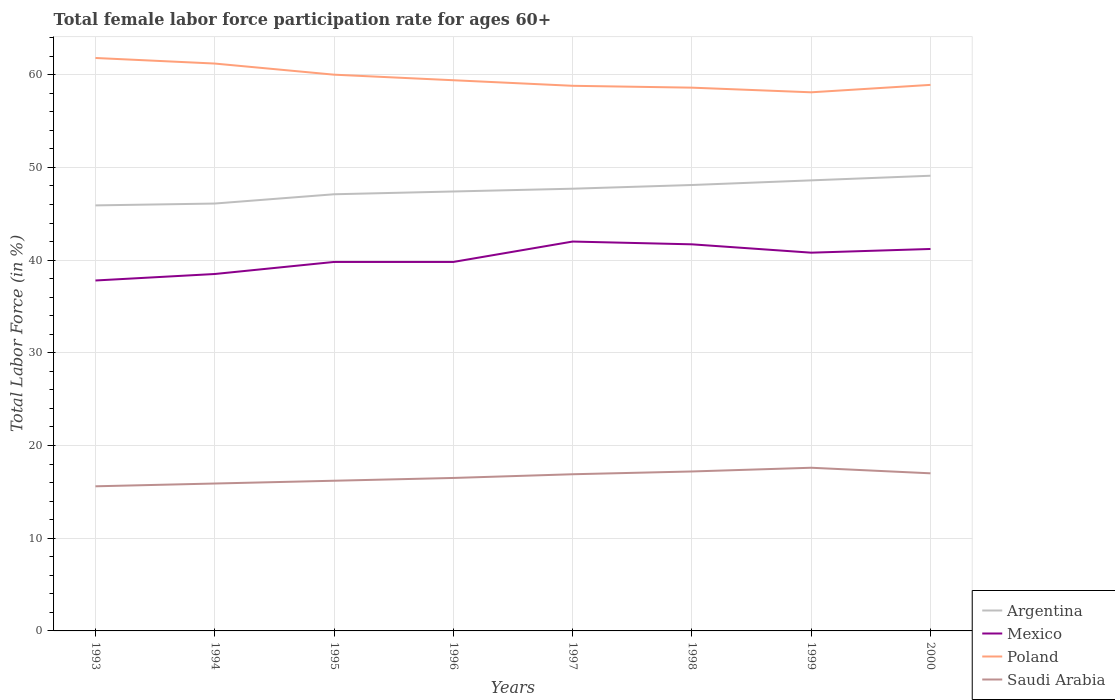Does the line corresponding to Saudi Arabia intersect with the line corresponding to Mexico?
Your answer should be very brief. No. Across all years, what is the maximum female labor force participation rate in Mexico?
Offer a terse response. 37.8. In which year was the female labor force participation rate in Saudi Arabia maximum?
Keep it short and to the point. 1993. What is the total female labor force participation rate in Saudi Arabia in the graph?
Your response must be concise. 0.2. What is the difference between the highest and the second highest female labor force participation rate in Mexico?
Make the answer very short. 4.2. What is the difference between the highest and the lowest female labor force participation rate in Argentina?
Your response must be concise. 4. Is the female labor force participation rate in Saudi Arabia strictly greater than the female labor force participation rate in Mexico over the years?
Make the answer very short. Yes. How many years are there in the graph?
Your response must be concise. 8. What is the difference between two consecutive major ticks on the Y-axis?
Provide a short and direct response. 10. Does the graph contain any zero values?
Make the answer very short. No. Does the graph contain grids?
Your answer should be compact. Yes. Where does the legend appear in the graph?
Your response must be concise. Bottom right. What is the title of the graph?
Your answer should be very brief. Total female labor force participation rate for ages 60+. Does "Curacao" appear as one of the legend labels in the graph?
Provide a succinct answer. No. What is the Total Labor Force (in %) in Argentina in 1993?
Your answer should be very brief. 45.9. What is the Total Labor Force (in %) of Mexico in 1993?
Keep it short and to the point. 37.8. What is the Total Labor Force (in %) of Poland in 1993?
Make the answer very short. 61.8. What is the Total Labor Force (in %) in Saudi Arabia in 1993?
Keep it short and to the point. 15.6. What is the Total Labor Force (in %) of Argentina in 1994?
Provide a short and direct response. 46.1. What is the Total Labor Force (in %) in Mexico in 1994?
Your answer should be compact. 38.5. What is the Total Labor Force (in %) of Poland in 1994?
Provide a succinct answer. 61.2. What is the Total Labor Force (in %) of Saudi Arabia in 1994?
Offer a very short reply. 15.9. What is the Total Labor Force (in %) in Argentina in 1995?
Give a very brief answer. 47.1. What is the Total Labor Force (in %) in Mexico in 1995?
Ensure brevity in your answer.  39.8. What is the Total Labor Force (in %) in Poland in 1995?
Provide a short and direct response. 60. What is the Total Labor Force (in %) of Saudi Arabia in 1995?
Your answer should be compact. 16.2. What is the Total Labor Force (in %) of Argentina in 1996?
Your answer should be compact. 47.4. What is the Total Labor Force (in %) of Mexico in 1996?
Provide a succinct answer. 39.8. What is the Total Labor Force (in %) of Poland in 1996?
Provide a succinct answer. 59.4. What is the Total Labor Force (in %) of Saudi Arabia in 1996?
Ensure brevity in your answer.  16.5. What is the Total Labor Force (in %) of Argentina in 1997?
Your response must be concise. 47.7. What is the Total Labor Force (in %) in Mexico in 1997?
Provide a short and direct response. 42. What is the Total Labor Force (in %) in Poland in 1997?
Offer a very short reply. 58.8. What is the Total Labor Force (in %) in Saudi Arabia in 1997?
Your answer should be very brief. 16.9. What is the Total Labor Force (in %) in Argentina in 1998?
Offer a terse response. 48.1. What is the Total Labor Force (in %) in Mexico in 1998?
Your answer should be compact. 41.7. What is the Total Labor Force (in %) in Poland in 1998?
Offer a terse response. 58.6. What is the Total Labor Force (in %) of Saudi Arabia in 1998?
Offer a terse response. 17.2. What is the Total Labor Force (in %) of Argentina in 1999?
Your answer should be very brief. 48.6. What is the Total Labor Force (in %) of Mexico in 1999?
Make the answer very short. 40.8. What is the Total Labor Force (in %) in Poland in 1999?
Your answer should be compact. 58.1. What is the Total Labor Force (in %) in Saudi Arabia in 1999?
Provide a short and direct response. 17.6. What is the Total Labor Force (in %) of Argentina in 2000?
Your answer should be compact. 49.1. What is the Total Labor Force (in %) in Mexico in 2000?
Give a very brief answer. 41.2. What is the Total Labor Force (in %) in Poland in 2000?
Make the answer very short. 58.9. Across all years, what is the maximum Total Labor Force (in %) of Argentina?
Give a very brief answer. 49.1. Across all years, what is the maximum Total Labor Force (in %) of Poland?
Offer a very short reply. 61.8. Across all years, what is the maximum Total Labor Force (in %) in Saudi Arabia?
Provide a succinct answer. 17.6. Across all years, what is the minimum Total Labor Force (in %) in Argentina?
Offer a very short reply. 45.9. Across all years, what is the minimum Total Labor Force (in %) of Mexico?
Your response must be concise. 37.8. Across all years, what is the minimum Total Labor Force (in %) of Poland?
Offer a very short reply. 58.1. Across all years, what is the minimum Total Labor Force (in %) in Saudi Arabia?
Offer a terse response. 15.6. What is the total Total Labor Force (in %) of Argentina in the graph?
Your answer should be compact. 380. What is the total Total Labor Force (in %) of Mexico in the graph?
Ensure brevity in your answer.  321.6. What is the total Total Labor Force (in %) in Poland in the graph?
Give a very brief answer. 476.8. What is the total Total Labor Force (in %) of Saudi Arabia in the graph?
Provide a succinct answer. 132.9. What is the difference between the Total Labor Force (in %) of Mexico in 1993 and that in 1994?
Make the answer very short. -0.7. What is the difference between the Total Labor Force (in %) of Poland in 1993 and that in 1994?
Make the answer very short. 0.6. What is the difference between the Total Labor Force (in %) of Saudi Arabia in 1993 and that in 1994?
Provide a succinct answer. -0.3. What is the difference between the Total Labor Force (in %) of Argentina in 1993 and that in 1995?
Provide a short and direct response. -1.2. What is the difference between the Total Labor Force (in %) of Mexico in 1993 and that in 1995?
Ensure brevity in your answer.  -2. What is the difference between the Total Labor Force (in %) in Saudi Arabia in 1993 and that in 1995?
Your response must be concise. -0.6. What is the difference between the Total Labor Force (in %) in Argentina in 1993 and that in 1996?
Your response must be concise. -1.5. What is the difference between the Total Labor Force (in %) in Poland in 1993 and that in 1996?
Your response must be concise. 2.4. What is the difference between the Total Labor Force (in %) in Saudi Arabia in 1993 and that in 1996?
Your response must be concise. -0.9. What is the difference between the Total Labor Force (in %) in Argentina in 1993 and that in 1997?
Your answer should be compact. -1.8. What is the difference between the Total Labor Force (in %) of Mexico in 1993 and that in 1997?
Provide a succinct answer. -4.2. What is the difference between the Total Labor Force (in %) in Mexico in 1993 and that in 1998?
Provide a succinct answer. -3.9. What is the difference between the Total Labor Force (in %) in Poland in 1993 and that in 1998?
Provide a succinct answer. 3.2. What is the difference between the Total Labor Force (in %) in Saudi Arabia in 1993 and that in 1998?
Your answer should be compact. -1.6. What is the difference between the Total Labor Force (in %) in Argentina in 1993 and that in 1999?
Ensure brevity in your answer.  -2.7. What is the difference between the Total Labor Force (in %) in Mexico in 1993 and that in 1999?
Your response must be concise. -3. What is the difference between the Total Labor Force (in %) in Poland in 1993 and that in 1999?
Offer a very short reply. 3.7. What is the difference between the Total Labor Force (in %) in Saudi Arabia in 1993 and that in 1999?
Keep it short and to the point. -2. What is the difference between the Total Labor Force (in %) of Argentina in 1993 and that in 2000?
Offer a terse response. -3.2. What is the difference between the Total Labor Force (in %) of Mexico in 1993 and that in 2000?
Provide a short and direct response. -3.4. What is the difference between the Total Labor Force (in %) of Poland in 1993 and that in 2000?
Provide a succinct answer. 2.9. What is the difference between the Total Labor Force (in %) of Argentina in 1994 and that in 1995?
Give a very brief answer. -1. What is the difference between the Total Labor Force (in %) in Poland in 1994 and that in 1995?
Your response must be concise. 1.2. What is the difference between the Total Labor Force (in %) of Poland in 1994 and that in 1996?
Offer a very short reply. 1.8. What is the difference between the Total Labor Force (in %) of Saudi Arabia in 1994 and that in 1996?
Your answer should be very brief. -0.6. What is the difference between the Total Labor Force (in %) of Argentina in 1994 and that in 1997?
Your answer should be very brief. -1.6. What is the difference between the Total Labor Force (in %) of Poland in 1994 and that in 1997?
Keep it short and to the point. 2.4. What is the difference between the Total Labor Force (in %) of Saudi Arabia in 1994 and that in 1998?
Your answer should be compact. -1.3. What is the difference between the Total Labor Force (in %) in Argentina in 1994 and that in 1999?
Make the answer very short. -2.5. What is the difference between the Total Labor Force (in %) of Saudi Arabia in 1994 and that in 1999?
Offer a terse response. -1.7. What is the difference between the Total Labor Force (in %) of Poland in 1994 and that in 2000?
Make the answer very short. 2.3. What is the difference between the Total Labor Force (in %) in Saudi Arabia in 1994 and that in 2000?
Ensure brevity in your answer.  -1.1. What is the difference between the Total Labor Force (in %) of Argentina in 1995 and that in 1996?
Your answer should be compact. -0.3. What is the difference between the Total Labor Force (in %) in Mexico in 1995 and that in 1997?
Give a very brief answer. -2.2. What is the difference between the Total Labor Force (in %) of Saudi Arabia in 1995 and that in 1997?
Keep it short and to the point. -0.7. What is the difference between the Total Labor Force (in %) in Poland in 1995 and that in 1998?
Give a very brief answer. 1.4. What is the difference between the Total Labor Force (in %) of Saudi Arabia in 1995 and that in 1998?
Provide a short and direct response. -1. What is the difference between the Total Labor Force (in %) in Argentina in 1995 and that in 1999?
Give a very brief answer. -1.5. What is the difference between the Total Labor Force (in %) of Poland in 1995 and that in 1999?
Give a very brief answer. 1.9. What is the difference between the Total Labor Force (in %) of Mexico in 1995 and that in 2000?
Make the answer very short. -1.4. What is the difference between the Total Labor Force (in %) of Poland in 1995 and that in 2000?
Provide a short and direct response. 1.1. What is the difference between the Total Labor Force (in %) of Mexico in 1996 and that in 1997?
Your response must be concise. -2.2. What is the difference between the Total Labor Force (in %) in Poland in 1996 and that in 1997?
Your response must be concise. 0.6. What is the difference between the Total Labor Force (in %) in Saudi Arabia in 1996 and that in 1997?
Offer a terse response. -0.4. What is the difference between the Total Labor Force (in %) of Mexico in 1996 and that in 1999?
Offer a terse response. -1. What is the difference between the Total Labor Force (in %) in Argentina in 1996 and that in 2000?
Provide a short and direct response. -1.7. What is the difference between the Total Labor Force (in %) in Mexico in 1996 and that in 2000?
Your answer should be compact. -1.4. What is the difference between the Total Labor Force (in %) of Argentina in 1997 and that in 1998?
Provide a succinct answer. -0.4. What is the difference between the Total Labor Force (in %) of Mexico in 1997 and that in 1998?
Provide a short and direct response. 0.3. What is the difference between the Total Labor Force (in %) in Saudi Arabia in 1997 and that in 1998?
Your response must be concise. -0.3. What is the difference between the Total Labor Force (in %) in Mexico in 1997 and that in 1999?
Provide a succinct answer. 1.2. What is the difference between the Total Labor Force (in %) of Saudi Arabia in 1997 and that in 1999?
Offer a very short reply. -0.7. What is the difference between the Total Labor Force (in %) of Argentina in 1997 and that in 2000?
Your response must be concise. -1.4. What is the difference between the Total Labor Force (in %) in Mexico in 1997 and that in 2000?
Ensure brevity in your answer.  0.8. What is the difference between the Total Labor Force (in %) in Argentina in 1998 and that in 1999?
Your answer should be compact. -0.5. What is the difference between the Total Labor Force (in %) in Poland in 1998 and that in 1999?
Provide a succinct answer. 0.5. What is the difference between the Total Labor Force (in %) in Saudi Arabia in 1998 and that in 1999?
Keep it short and to the point. -0.4. What is the difference between the Total Labor Force (in %) in Mexico in 1998 and that in 2000?
Your answer should be compact. 0.5. What is the difference between the Total Labor Force (in %) of Saudi Arabia in 1998 and that in 2000?
Your response must be concise. 0.2. What is the difference between the Total Labor Force (in %) of Argentina in 1999 and that in 2000?
Provide a short and direct response. -0.5. What is the difference between the Total Labor Force (in %) in Mexico in 1999 and that in 2000?
Give a very brief answer. -0.4. What is the difference between the Total Labor Force (in %) of Poland in 1999 and that in 2000?
Keep it short and to the point. -0.8. What is the difference between the Total Labor Force (in %) of Argentina in 1993 and the Total Labor Force (in %) of Poland in 1994?
Your response must be concise. -15.3. What is the difference between the Total Labor Force (in %) of Mexico in 1993 and the Total Labor Force (in %) of Poland in 1994?
Your response must be concise. -23.4. What is the difference between the Total Labor Force (in %) of Mexico in 1993 and the Total Labor Force (in %) of Saudi Arabia in 1994?
Provide a short and direct response. 21.9. What is the difference between the Total Labor Force (in %) in Poland in 1993 and the Total Labor Force (in %) in Saudi Arabia in 1994?
Ensure brevity in your answer.  45.9. What is the difference between the Total Labor Force (in %) in Argentina in 1993 and the Total Labor Force (in %) in Mexico in 1995?
Your response must be concise. 6.1. What is the difference between the Total Labor Force (in %) in Argentina in 1993 and the Total Labor Force (in %) in Poland in 1995?
Offer a terse response. -14.1. What is the difference between the Total Labor Force (in %) of Argentina in 1993 and the Total Labor Force (in %) of Saudi Arabia in 1995?
Provide a short and direct response. 29.7. What is the difference between the Total Labor Force (in %) in Mexico in 1993 and the Total Labor Force (in %) in Poland in 1995?
Make the answer very short. -22.2. What is the difference between the Total Labor Force (in %) in Mexico in 1993 and the Total Labor Force (in %) in Saudi Arabia in 1995?
Make the answer very short. 21.6. What is the difference between the Total Labor Force (in %) of Poland in 1993 and the Total Labor Force (in %) of Saudi Arabia in 1995?
Provide a short and direct response. 45.6. What is the difference between the Total Labor Force (in %) of Argentina in 1993 and the Total Labor Force (in %) of Saudi Arabia in 1996?
Your answer should be compact. 29.4. What is the difference between the Total Labor Force (in %) of Mexico in 1993 and the Total Labor Force (in %) of Poland in 1996?
Your answer should be very brief. -21.6. What is the difference between the Total Labor Force (in %) in Mexico in 1993 and the Total Labor Force (in %) in Saudi Arabia in 1996?
Ensure brevity in your answer.  21.3. What is the difference between the Total Labor Force (in %) in Poland in 1993 and the Total Labor Force (in %) in Saudi Arabia in 1996?
Offer a very short reply. 45.3. What is the difference between the Total Labor Force (in %) of Argentina in 1993 and the Total Labor Force (in %) of Mexico in 1997?
Your answer should be very brief. 3.9. What is the difference between the Total Labor Force (in %) in Mexico in 1993 and the Total Labor Force (in %) in Saudi Arabia in 1997?
Offer a terse response. 20.9. What is the difference between the Total Labor Force (in %) of Poland in 1993 and the Total Labor Force (in %) of Saudi Arabia in 1997?
Give a very brief answer. 44.9. What is the difference between the Total Labor Force (in %) in Argentina in 1993 and the Total Labor Force (in %) in Mexico in 1998?
Your answer should be compact. 4.2. What is the difference between the Total Labor Force (in %) of Argentina in 1993 and the Total Labor Force (in %) of Saudi Arabia in 1998?
Make the answer very short. 28.7. What is the difference between the Total Labor Force (in %) in Mexico in 1993 and the Total Labor Force (in %) in Poland in 1998?
Make the answer very short. -20.8. What is the difference between the Total Labor Force (in %) of Mexico in 1993 and the Total Labor Force (in %) of Saudi Arabia in 1998?
Keep it short and to the point. 20.6. What is the difference between the Total Labor Force (in %) of Poland in 1993 and the Total Labor Force (in %) of Saudi Arabia in 1998?
Your answer should be compact. 44.6. What is the difference between the Total Labor Force (in %) of Argentina in 1993 and the Total Labor Force (in %) of Mexico in 1999?
Provide a short and direct response. 5.1. What is the difference between the Total Labor Force (in %) in Argentina in 1993 and the Total Labor Force (in %) in Poland in 1999?
Provide a short and direct response. -12.2. What is the difference between the Total Labor Force (in %) of Argentina in 1993 and the Total Labor Force (in %) of Saudi Arabia in 1999?
Provide a short and direct response. 28.3. What is the difference between the Total Labor Force (in %) in Mexico in 1993 and the Total Labor Force (in %) in Poland in 1999?
Your answer should be compact. -20.3. What is the difference between the Total Labor Force (in %) of Mexico in 1993 and the Total Labor Force (in %) of Saudi Arabia in 1999?
Make the answer very short. 20.2. What is the difference between the Total Labor Force (in %) of Poland in 1993 and the Total Labor Force (in %) of Saudi Arabia in 1999?
Give a very brief answer. 44.2. What is the difference between the Total Labor Force (in %) of Argentina in 1993 and the Total Labor Force (in %) of Poland in 2000?
Make the answer very short. -13. What is the difference between the Total Labor Force (in %) in Argentina in 1993 and the Total Labor Force (in %) in Saudi Arabia in 2000?
Provide a succinct answer. 28.9. What is the difference between the Total Labor Force (in %) in Mexico in 1993 and the Total Labor Force (in %) in Poland in 2000?
Make the answer very short. -21.1. What is the difference between the Total Labor Force (in %) of Mexico in 1993 and the Total Labor Force (in %) of Saudi Arabia in 2000?
Offer a terse response. 20.8. What is the difference between the Total Labor Force (in %) in Poland in 1993 and the Total Labor Force (in %) in Saudi Arabia in 2000?
Give a very brief answer. 44.8. What is the difference between the Total Labor Force (in %) in Argentina in 1994 and the Total Labor Force (in %) in Mexico in 1995?
Provide a succinct answer. 6.3. What is the difference between the Total Labor Force (in %) in Argentina in 1994 and the Total Labor Force (in %) in Poland in 1995?
Offer a terse response. -13.9. What is the difference between the Total Labor Force (in %) in Argentina in 1994 and the Total Labor Force (in %) in Saudi Arabia in 1995?
Your response must be concise. 29.9. What is the difference between the Total Labor Force (in %) in Mexico in 1994 and the Total Labor Force (in %) in Poland in 1995?
Ensure brevity in your answer.  -21.5. What is the difference between the Total Labor Force (in %) in Mexico in 1994 and the Total Labor Force (in %) in Saudi Arabia in 1995?
Keep it short and to the point. 22.3. What is the difference between the Total Labor Force (in %) in Argentina in 1994 and the Total Labor Force (in %) in Poland in 1996?
Keep it short and to the point. -13.3. What is the difference between the Total Labor Force (in %) of Argentina in 1994 and the Total Labor Force (in %) of Saudi Arabia in 1996?
Make the answer very short. 29.6. What is the difference between the Total Labor Force (in %) in Mexico in 1994 and the Total Labor Force (in %) in Poland in 1996?
Your answer should be very brief. -20.9. What is the difference between the Total Labor Force (in %) of Poland in 1994 and the Total Labor Force (in %) of Saudi Arabia in 1996?
Ensure brevity in your answer.  44.7. What is the difference between the Total Labor Force (in %) in Argentina in 1994 and the Total Labor Force (in %) in Saudi Arabia in 1997?
Ensure brevity in your answer.  29.2. What is the difference between the Total Labor Force (in %) of Mexico in 1994 and the Total Labor Force (in %) of Poland in 1997?
Ensure brevity in your answer.  -20.3. What is the difference between the Total Labor Force (in %) of Mexico in 1994 and the Total Labor Force (in %) of Saudi Arabia in 1997?
Offer a terse response. 21.6. What is the difference between the Total Labor Force (in %) in Poland in 1994 and the Total Labor Force (in %) in Saudi Arabia in 1997?
Keep it short and to the point. 44.3. What is the difference between the Total Labor Force (in %) in Argentina in 1994 and the Total Labor Force (in %) in Mexico in 1998?
Your answer should be compact. 4.4. What is the difference between the Total Labor Force (in %) of Argentina in 1994 and the Total Labor Force (in %) of Poland in 1998?
Your answer should be compact. -12.5. What is the difference between the Total Labor Force (in %) in Argentina in 1994 and the Total Labor Force (in %) in Saudi Arabia in 1998?
Keep it short and to the point. 28.9. What is the difference between the Total Labor Force (in %) of Mexico in 1994 and the Total Labor Force (in %) of Poland in 1998?
Make the answer very short. -20.1. What is the difference between the Total Labor Force (in %) in Mexico in 1994 and the Total Labor Force (in %) in Saudi Arabia in 1998?
Your response must be concise. 21.3. What is the difference between the Total Labor Force (in %) in Poland in 1994 and the Total Labor Force (in %) in Saudi Arabia in 1998?
Give a very brief answer. 44. What is the difference between the Total Labor Force (in %) of Argentina in 1994 and the Total Labor Force (in %) of Mexico in 1999?
Your answer should be compact. 5.3. What is the difference between the Total Labor Force (in %) in Argentina in 1994 and the Total Labor Force (in %) in Saudi Arabia in 1999?
Make the answer very short. 28.5. What is the difference between the Total Labor Force (in %) in Mexico in 1994 and the Total Labor Force (in %) in Poland in 1999?
Your answer should be compact. -19.6. What is the difference between the Total Labor Force (in %) in Mexico in 1994 and the Total Labor Force (in %) in Saudi Arabia in 1999?
Offer a very short reply. 20.9. What is the difference between the Total Labor Force (in %) in Poland in 1994 and the Total Labor Force (in %) in Saudi Arabia in 1999?
Your response must be concise. 43.6. What is the difference between the Total Labor Force (in %) in Argentina in 1994 and the Total Labor Force (in %) in Mexico in 2000?
Offer a terse response. 4.9. What is the difference between the Total Labor Force (in %) of Argentina in 1994 and the Total Labor Force (in %) of Poland in 2000?
Offer a very short reply. -12.8. What is the difference between the Total Labor Force (in %) in Argentina in 1994 and the Total Labor Force (in %) in Saudi Arabia in 2000?
Offer a very short reply. 29.1. What is the difference between the Total Labor Force (in %) of Mexico in 1994 and the Total Labor Force (in %) of Poland in 2000?
Your response must be concise. -20.4. What is the difference between the Total Labor Force (in %) of Poland in 1994 and the Total Labor Force (in %) of Saudi Arabia in 2000?
Make the answer very short. 44.2. What is the difference between the Total Labor Force (in %) in Argentina in 1995 and the Total Labor Force (in %) in Mexico in 1996?
Give a very brief answer. 7.3. What is the difference between the Total Labor Force (in %) of Argentina in 1995 and the Total Labor Force (in %) of Poland in 1996?
Provide a short and direct response. -12.3. What is the difference between the Total Labor Force (in %) of Argentina in 1995 and the Total Labor Force (in %) of Saudi Arabia in 1996?
Your answer should be compact. 30.6. What is the difference between the Total Labor Force (in %) of Mexico in 1995 and the Total Labor Force (in %) of Poland in 1996?
Your answer should be compact. -19.6. What is the difference between the Total Labor Force (in %) of Mexico in 1995 and the Total Labor Force (in %) of Saudi Arabia in 1996?
Offer a terse response. 23.3. What is the difference between the Total Labor Force (in %) of Poland in 1995 and the Total Labor Force (in %) of Saudi Arabia in 1996?
Keep it short and to the point. 43.5. What is the difference between the Total Labor Force (in %) of Argentina in 1995 and the Total Labor Force (in %) of Mexico in 1997?
Offer a very short reply. 5.1. What is the difference between the Total Labor Force (in %) of Argentina in 1995 and the Total Labor Force (in %) of Poland in 1997?
Make the answer very short. -11.7. What is the difference between the Total Labor Force (in %) in Argentina in 1995 and the Total Labor Force (in %) in Saudi Arabia in 1997?
Offer a very short reply. 30.2. What is the difference between the Total Labor Force (in %) of Mexico in 1995 and the Total Labor Force (in %) of Poland in 1997?
Provide a short and direct response. -19. What is the difference between the Total Labor Force (in %) in Mexico in 1995 and the Total Labor Force (in %) in Saudi Arabia in 1997?
Your response must be concise. 22.9. What is the difference between the Total Labor Force (in %) in Poland in 1995 and the Total Labor Force (in %) in Saudi Arabia in 1997?
Give a very brief answer. 43.1. What is the difference between the Total Labor Force (in %) of Argentina in 1995 and the Total Labor Force (in %) of Mexico in 1998?
Provide a short and direct response. 5.4. What is the difference between the Total Labor Force (in %) of Argentina in 1995 and the Total Labor Force (in %) of Saudi Arabia in 1998?
Provide a short and direct response. 29.9. What is the difference between the Total Labor Force (in %) of Mexico in 1995 and the Total Labor Force (in %) of Poland in 1998?
Keep it short and to the point. -18.8. What is the difference between the Total Labor Force (in %) of Mexico in 1995 and the Total Labor Force (in %) of Saudi Arabia in 1998?
Provide a short and direct response. 22.6. What is the difference between the Total Labor Force (in %) in Poland in 1995 and the Total Labor Force (in %) in Saudi Arabia in 1998?
Keep it short and to the point. 42.8. What is the difference between the Total Labor Force (in %) in Argentina in 1995 and the Total Labor Force (in %) in Poland in 1999?
Offer a terse response. -11. What is the difference between the Total Labor Force (in %) of Argentina in 1995 and the Total Labor Force (in %) of Saudi Arabia in 1999?
Offer a terse response. 29.5. What is the difference between the Total Labor Force (in %) of Mexico in 1995 and the Total Labor Force (in %) of Poland in 1999?
Provide a short and direct response. -18.3. What is the difference between the Total Labor Force (in %) in Mexico in 1995 and the Total Labor Force (in %) in Saudi Arabia in 1999?
Keep it short and to the point. 22.2. What is the difference between the Total Labor Force (in %) of Poland in 1995 and the Total Labor Force (in %) of Saudi Arabia in 1999?
Keep it short and to the point. 42.4. What is the difference between the Total Labor Force (in %) of Argentina in 1995 and the Total Labor Force (in %) of Poland in 2000?
Provide a succinct answer. -11.8. What is the difference between the Total Labor Force (in %) of Argentina in 1995 and the Total Labor Force (in %) of Saudi Arabia in 2000?
Your answer should be compact. 30.1. What is the difference between the Total Labor Force (in %) in Mexico in 1995 and the Total Labor Force (in %) in Poland in 2000?
Offer a terse response. -19.1. What is the difference between the Total Labor Force (in %) of Mexico in 1995 and the Total Labor Force (in %) of Saudi Arabia in 2000?
Offer a terse response. 22.8. What is the difference between the Total Labor Force (in %) of Argentina in 1996 and the Total Labor Force (in %) of Mexico in 1997?
Your answer should be very brief. 5.4. What is the difference between the Total Labor Force (in %) of Argentina in 1996 and the Total Labor Force (in %) of Poland in 1997?
Ensure brevity in your answer.  -11.4. What is the difference between the Total Labor Force (in %) of Argentina in 1996 and the Total Labor Force (in %) of Saudi Arabia in 1997?
Provide a succinct answer. 30.5. What is the difference between the Total Labor Force (in %) of Mexico in 1996 and the Total Labor Force (in %) of Saudi Arabia in 1997?
Provide a short and direct response. 22.9. What is the difference between the Total Labor Force (in %) of Poland in 1996 and the Total Labor Force (in %) of Saudi Arabia in 1997?
Your response must be concise. 42.5. What is the difference between the Total Labor Force (in %) in Argentina in 1996 and the Total Labor Force (in %) in Mexico in 1998?
Offer a very short reply. 5.7. What is the difference between the Total Labor Force (in %) of Argentina in 1996 and the Total Labor Force (in %) of Poland in 1998?
Offer a very short reply. -11.2. What is the difference between the Total Labor Force (in %) in Argentina in 1996 and the Total Labor Force (in %) in Saudi Arabia in 1998?
Give a very brief answer. 30.2. What is the difference between the Total Labor Force (in %) of Mexico in 1996 and the Total Labor Force (in %) of Poland in 1998?
Provide a succinct answer. -18.8. What is the difference between the Total Labor Force (in %) of Mexico in 1996 and the Total Labor Force (in %) of Saudi Arabia in 1998?
Make the answer very short. 22.6. What is the difference between the Total Labor Force (in %) of Poland in 1996 and the Total Labor Force (in %) of Saudi Arabia in 1998?
Offer a terse response. 42.2. What is the difference between the Total Labor Force (in %) in Argentina in 1996 and the Total Labor Force (in %) in Mexico in 1999?
Provide a short and direct response. 6.6. What is the difference between the Total Labor Force (in %) of Argentina in 1996 and the Total Labor Force (in %) of Poland in 1999?
Your response must be concise. -10.7. What is the difference between the Total Labor Force (in %) in Argentina in 1996 and the Total Labor Force (in %) in Saudi Arabia in 1999?
Keep it short and to the point. 29.8. What is the difference between the Total Labor Force (in %) in Mexico in 1996 and the Total Labor Force (in %) in Poland in 1999?
Make the answer very short. -18.3. What is the difference between the Total Labor Force (in %) of Poland in 1996 and the Total Labor Force (in %) of Saudi Arabia in 1999?
Offer a terse response. 41.8. What is the difference between the Total Labor Force (in %) of Argentina in 1996 and the Total Labor Force (in %) of Mexico in 2000?
Keep it short and to the point. 6.2. What is the difference between the Total Labor Force (in %) of Argentina in 1996 and the Total Labor Force (in %) of Poland in 2000?
Your answer should be very brief. -11.5. What is the difference between the Total Labor Force (in %) in Argentina in 1996 and the Total Labor Force (in %) in Saudi Arabia in 2000?
Offer a very short reply. 30.4. What is the difference between the Total Labor Force (in %) in Mexico in 1996 and the Total Labor Force (in %) in Poland in 2000?
Ensure brevity in your answer.  -19.1. What is the difference between the Total Labor Force (in %) in Mexico in 1996 and the Total Labor Force (in %) in Saudi Arabia in 2000?
Your answer should be compact. 22.8. What is the difference between the Total Labor Force (in %) of Poland in 1996 and the Total Labor Force (in %) of Saudi Arabia in 2000?
Your answer should be compact. 42.4. What is the difference between the Total Labor Force (in %) in Argentina in 1997 and the Total Labor Force (in %) in Mexico in 1998?
Offer a very short reply. 6. What is the difference between the Total Labor Force (in %) in Argentina in 1997 and the Total Labor Force (in %) in Saudi Arabia in 1998?
Give a very brief answer. 30.5. What is the difference between the Total Labor Force (in %) of Mexico in 1997 and the Total Labor Force (in %) of Poland in 1998?
Your answer should be very brief. -16.6. What is the difference between the Total Labor Force (in %) of Mexico in 1997 and the Total Labor Force (in %) of Saudi Arabia in 1998?
Ensure brevity in your answer.  24.8. What is the difference between the Total Labor Force (in %) of Poland in 1997 and the Total Labor Force (in %) of Saudi Arabia in 1998?
Give a very brief answer. 41.6. What is the difference between the Total Labor Force (in %) in Argentina in 1997 and the Total Labor Force (in %) in Saudi Arabia in 1999?
Provide a succinct answer. 30.1. What is the difference between the Total Labor Force (in %) in Mexico in 1997 and the Total Labor Force (in %) in Poland in 1999?
Ensure brevity in your answer.  -16.1. What is the difference between the Total Labor Force (in %) in Mexico in 1997 and the Total Labor Force (in %) in Saudi Arabia in 1999?
Your response must be concise. 24.4. What is the difference between the Total Labor Force (in %) in Poland in 1997 and the Total Labor Force (in %) in Saudi Arabia in 1999?
Keep it short and to the point. 41.2. What is the difference between the Total Labor Force (in %) in Argentina in 1997 and the Total Labor Force (in %) in Saudi Arabia in 2000?
Give a very brief answer. 30.7. What is the difference between the Total Labor Force (in %) of Mexico in 1997 and the Total Labor Force (in %) of Poland in 2000?
Offer a terse response. -16.9. What is the difference between the Total Labor Force (in %) in Mexico in 1997 and the Total Labor Force (in %) in Saudi Arabia in 2000?
Your answer should be compact. 25. What is the difference between the Total Labor Force (in %) in Poland in 1997 and the Total Labor Force (in %) in Saudi Arabia in 2000?
Give a very brief answer. 41.8. What is the difference between the Total Labor Force (in %) in Argentina in 1998 and the Total Labor Force (in %) in Poland in 1999?
Provide a succinct answer. -10. What is the difference between the Total Labor Force (in %) of Argentina in 1998 and the Total Labor Force (in %) of Saudi Arabia in 1999?
Offer a very short reply. 30.5. What is the difference between the Total Labor Force (in %) of Mexico in 1998 and the Total Labor Force (in %) of Poland in 1999?
Your answer should be compact. -16.4. What is the difference between the Total Labor Force (in %) of Mexico in 1998 and the Total Labor Force (in %) of Saudi Arabia in 1999?
Offer a very short reply. 24.1. What is the difference between the Total Labor Force (in %) of Poland in 1998 and the Total Labor Force (in %) of Saudi Arabia in 1999?
Your answer should be very brief. 41. What is the difference between the Total Labor Force (in %) of Argentina in 1998 and the Total Labor Force (in %) of Saudi Arabia in 2000?
Offer a terse response. 31.1. What is the difference between the Total Labor Force (in %) in Mexico in 1998 and the Total Labor Force (in %) in Poland in 2000?
Make the answer very short. -17.2. What is the difference between the Total Labor Force (in %) of Mexico in 1998 and the Total Labor Force (in %) of Saudi Arabia in 2000?
Provide a short and direct response. 24.7. What is the difference between the Total Labor Force (in %) in Poland in 1998 and the Total Labor Force (in %) in Saudi Arabia in 2000?
Give a very brief answer. 41.6. What is the difference between the Total Labor Force (in %) in Argentina in 1999 and the Total Labor Force (in %) in Mexico in 2000?
Keep it short and to the point. 7.4. What is the difference between the Total Labor Force (in %) of Argentina in 1999 and the Total Labor Force (in %) of Saudi Arabia in 2000?
Give a very brief answer. 31.6. What is the difference between the Total Labor Force (in %) of Mexico in 1999 and the Total Labor Force (in %) of Poland in 2000?
Keep it short and to the point. -18.1. What is the difference between the Total Labor Force (in %) in Mexico in 1999 and the Total Labor Force (in %) in Saudi Arabia in 2000?
Offer a terse response. 23.8. What is the difference between the Total Labor Force (in %) in Poland in 1999 and the Total Labor Force (in %) in Saudi Arabia in 2000?
Offer a terse response. 41.1. What is the average Total Labor Force (in %) of Argentina per year?
Give a very brief answer. 47.5. What is the average Total Labor Force (in %) of Mexico per year?
Ensure brevity in your answer.  40.2. What is the average Total Labor Force (in %) of Poland per year?
Offer a terse response. 59.6. What is the average Total Labor Force (in %) of Saudi Arabia per year?
Your response must be concise. 16.61. In the year 1993, what is the difference between the Total Labor Force (in %) in Argentina and Total Labor Force (in %) in Mexico?
Give a very brief answer. 8.1. In the year 1993, what is the difference between the Total Labor Force (in %) in Argentina and Total Labor Force (in %) in Poland?
Offer a very short reply. -15.9. In the year 1993, what is the difference between the Total Labor Force (in %) in Argentina and Total Labor Force (in %) in Saudi Arabia?
Provide a short and direct response. 30.3. In the year 1993, what is the difference between the Total Labor Force (in %) in Poland and Total Labor Force (in %) in Saudi Arabia?
Keep it short and to the point. 46.2. In the year 1994, what is the difference between the Total Labor Force (in %) of Argentina and Total Labor Force (in %) of Mexico?
Provide a succinct answer. 7.6. In the year 1994, what is the difference between the Total Labor Force (in %) in Argentina and Total Labor Force (in %) in Poland?
Your answer should be compact. -15.1. In the year 1994, what is the difference between the Total Labor Force (in %) of Argentina and Total Labor Force (in %) of Saudi Arabia?
Provide a succinct answer. 30.2. In the year 1994, what is the difference between the Total Labor Force (in %) in Mexico and Total Labor Force (in %) in Poland?
Your response must be concise. -22.7. In the year 1994, what is the difference between the Total Labor Force (in %) in Mexico and Total Labor Force (in %) in Saudi Arabia?
Your answer should be very brief. 22.6. In the year 1994, what is the difference between the Total Labor Force (in %) of Poland and Total Labor Force (in %) of Saudi Arabia?
Your answer should be very brief. 45.3. In the year 1995, what is the difference between the Total Labor Force (in %) of Argentina and Total Labor Force (in %) of Poland?
Offer a very short reply. -12.9. In the year 1995, what is the difference between the Total Labor Force (in %) in Argentina and Total Labor Force (in %) in Saudi Arabia?
Your answer should be compact. 30.9. In the year 1995, what is the difference between the Total Labor Force (in %) in Mexico and Total Labor Force (in %) in Poland?
Give a very brief answer. -20.2. In the year 1995, what is the difference between the Total Labor Force (in %) of Mexico and Total Labor Force (in %) of Saudi Arabia?
Your response must be concise. 23.6. In the year 1995, what is the difference between the Total Labor Force (in %) of Poland and Total Labor Force (in %) of Saudi Arabia?
Provide a succinct answer. 43.8. In the year 1996, what is the difference between the Total Labor Force (in %) in Argentina and Total Labor Force (in %) in Mexico?
Offer a terse response. 7.6. In the year 1996, what is the difference between the Total Labor Force (in %) of Argentina and Total Labor Force (in %) of Saudi Arabia?
Ensure brevity in your answer.  30.9. In the year 1996, what is the difference between the Total Labor Force (in %) of Mexico and Total Labor Force (in %) of Poland?
Make the answer very short. -19.6. In the year 1996, what is the difference between the Total Labor Force (in %) of Mexico and Total Labor Force (in %) of Saudi Arabia?
Make the answer very short. 23.3. In the year 1996, what is the difference between the Total Labor Force (in %) of Poland and Total Labor Force (in %) of Saudi Arabia?
Keep it short and to the point. 42.9. In the year 1997, what is the difference between the Total Labor Force (in %) of Argentina and Total Labor Force (in %) of Poland?
Offer a terse response. -11.1. In the year 1997, what is the difference between the Total Labor Force (in %) in Argentina and Total Labor Force (in %) in Saudi Arabia?
Ensure brevity in your answer.  30.8. In the year 1997, what is the difference between the Total Labor Force (in %) in Mexico and Total Labor Force (in %) in Poland?
Make the answer very short. -16.8. In the year 1997, what is the difference between the Total Labor Force (in %) of Mexico and Total Labor Force (in %) of Saudi Arabia?
Make the answer very short. 25.1. In the year 1997, what is the difference between the Total Labor Force (in %) of Poland and Total Labor Force (in %) of Saudi Arabia?
Your answer should be compact. 41.9. In the year 1998, what is the difference between the Total Labor Force (in %) in Argentina and Total Labor Force (in %) in Saudi Arabia?
Your answer should be compact. 30.9. In the year 1998, what is the difference between the Total Labor Force (in %) of Mexico and Total Labor Force (in %) of Poland?
Your answer should be very brief. -16.9. In the year 1998, what is the difference between the Total Labor Force (in %) of Poland and Total Labor Force (in %) of Saudi Arabia?
Provide a short and direct response. 41.4. In the year 1999, what is the difference between the Total Labor Force (in %) of Argentina and Total Labor Force (in %) of Poland?
Provide a short and direct response. -9.5. In the year 1999, what is the difference between the Total Labor Force (in %) of Mexico and Total Labor Force (in %) of Poland?
Provide a succinct answer. -17.3. In the year 1999, what is the difference between the Total Labor Force (in %) of Mexico and Total Labor Force (in %) of Saudi Arabia?
Your answer should be compact. 23.2. In the year 1999, what is the difference between the Total Labor Force (in %) of Poland and Total Labor Force (in %) of Saudi Arabia?
Provide a succinct answer. 40.5. In the year 2000, what is the difference between the Total Labor Force (in %) in Argentina and Total Labor Force (in %) in Poland?
Provide a succinct answer. -9.8. In the year 2000, what is the difference between the Total Labor Force (in %) of Argentina and Total Labor Force (in %) of Saudi Arabia?
Offer a terse response. 32.1. In the year 2000, what is the difference between the Total Labor Force (in %) of Mexico and Total Labor Force (in %) of Poland?
Provide a succinct answer. -17.7. In the year 2000, what is the difference between the Total Labor Force (in %) in Mexico and Total Labor Force (in %) in Saudi Arabia?
Make the answer very short. 24.2. In the year 2000, what is the difference between the Total Labor Force (in %) in Poland and Total Labor Force (in %) in Saudi Arabia?
Your answer should be compact. 41.9. What is the ratio of the Total Labor Force (in %) in Mexico in 1993 to that in 1994?
Offer a terse response. 0.98. What is the ratio of the Total Labor Force (in %) in Poland in 1993 to that in 1994?
Your answer should be very brief. 1.01. What is the ratio of the Total Labor Force (in %) in Saudi Arabia in 1993 to that in 1994?
Offer a terse response. 0.98. What is the ratio of the Total Labor Force (in %) in Argentina in 1993 to that in 1995?
Your response must be concise. 0.97. What is the ratio of the Total Labor Force (in %) in Mexico in 1993 to that in 1995?
Your answer should be compact. 0.95. What is the ratio of the Total Labor Force (in %) in Saudi Arabia in 1993 to that in 1995?
Provide a short and direct response. 0.96. What is the ratio of the Total Labor Force (in %) of Argentina in 1993 to that in 1996?
Provide a short and direct response. 0.97. What is the ratio of the Total Labor Force (in %) in Mexico in 1993 to that in 1996?
Give a very brief answer. 0.95. What is the ratio of the Total Labor Force (in %) of Poland in 1993 to that in 1996?
Keep it short and to the point. 1.04. What is the ratio of the Total Labor Force (in %) in Saudi Arabia in 1993 to that in 1996?
Give a very brief answer. 0.95. What is the ratio of the Total Labor Force (in %) of Argentina in 1993 to that in 1997?
Your answer should be very brief. 0.96. What is the ratio of the Total Labor Force (in %) in Mexico in 1993 to that in 1997?
Offer a terse response. 0.9. What is the ratio of the Total Labor Force (in %) in Poland in 1993 to that in 1997?
Your answer should be very brief. 1.05. What is the ratio of the Total Labor Force (in %) in Argentina in 1993 to that in 1998?
Provide a succinct answer. 0.95. What is the ratio of the Total Labor Force (in %) in Mexico in 1993 to that in 1998?
Keep it short and to the point. 0.91. What is the ratio of the Total Labor Force (in %) in Poland in 1993 to that in 1998?
Your answer should be very brief. 1.05. What is the ratio of the Total Labor Force (in %) of Saudi Arabia in 1993 to that in 1998?
Offer a terse response. 0.91. What is the ratio of the Total Labor Force (in %) in Argentina in 1993 to that in 1999?
Offer a terse response. 0.94. What is the ratio of the Total Labor Force (in %) in Mexico in 1993 to that in 1999?
Provide a short and direct response. 0.93. What is the ratio of the Total Labor Force (in %) of Poland in 1993 to that in 1999?
Keep it short and to the point. 1.06. What is the ratio of the Total Labor Force (in %) of Saudi Arabia in 1993 to that in 1999?
Provide a succinct answer. 0.89. What is the ratio of the Total Labor Force (in %) of Argentina in 1993 to that in 2000?
Make the answer very short. 0.93. What is the ratio of the Total Labor Force (in %) of Mexico in 1993 to that in 2000?
Provide a succinct answer. 0.92. What is the ratio of the Total Labor Force (in %) in Poland in 1993 to that in 2000?
Offer a very short reply. 1.05. What is the ratio of the Total Labor Force (in %) of Saudi Arabia in 1993 to that in 2000?
Your answer should be compact. 0.92. What is the ratio of the Total Labor Force (in %) of Argentina in 1994 to that in 1995?
Ensure brevity in your answer.  0.98. What is the ratio of the Total Labor Force (in %) of Mexico in 1994 to that in 1995?
Offer a very short reply. 0.97. What is the ratio of the Total Labor Force (in %) of Poland in 1994 to that in 1995?
Provide a succinct answer. 1.02. What is the ratio of the Total Labor Force (in %) of Saudi Arabia in 1994 to that in 1995?
Make the answer very short. 0.98. What is the ratio of the Total Labor Force (in %) of Argentina in 1994 to that in 1996?
Offer a very short reply. 0.97. What is the ratio of the Total Labor Force (in %) in Mexico in 1994 to that in 1996?
Ensure brevity in your answer.  0.97. What is the ratio of the Total Labor Force (in %) in Poland in 1994 to that in 1996?
Provide a succinct answer. 1.03. What is the ratio of the Total Labor Force (in %) in Saudi Arabia in 1994 to that in 1996?
Your response must be concise. 0.96. What is the ratio of the Total Labor Force (in %) in Argentina in 1994 to that in 1997?
Make the answer very short. 0.97. What is the ratio of the Total Labor Force (in %) of Poland in 1994 to that in 1997?
Your answer should be compact. 1.04. What is the ratio of the Total Labor Force (in %) of Saudi Arabia in 1994 to that in 1997?
Offer a terse response. 0.94. What is the ratio of the Total Labor Force (in %) in Argentina in 1994 to that in 1998?
Ensure brevity in your answer.  0.96. What is the ratio of the Total Labor Force (in %) in Mexico in 1994 to that in 1998?
Your response must be concise. 0.92. What is the ratio of the Total Labor Force (in %) in Poland in 1994 to that in 1998?
Provide a short and direct response. 1.04. What is the ratio of the Total Labor Force (in %) of Saudi Arabia in 1994 to that in 1998?
Provide a short and direct response. 0.92. What is the ratio of the Total Labor Force (in %) in Argentina in 1994 to that in 1999?
Your answer should be very brief. 0.95. What is the ratio of the Total Labor Force (in %) in Mexico in 1994 to that in 1999?
Your response must be concise. 0.94. What is the ratio of the Total Labor Force (in %) in Poland in 1994 to that in 1999?
Your answer should be compact. 1.05. What is the ratio of the Total Labor Force (in %) of Saudi Arabia in 1994 to that in 1999?
Give a very brief answer. 0.9. What is the ratio of the Total Labor Force (in %) of Argentina in 1994 to that in 2000?
Offer a very short reply. 0.94. What is the ratio of the Total Labor Force (in %) in Mexico in 1994 to that in 2000?
Keep it short and to the point. 0.93. What is the ratio of the Total Labor Force (in %) in Poland in 1994 to that in 2000?
Offer a terse response. 1.04. What is the ratio of the Total Labor Force (in %) of Saudi Arabia in 1994 to that in 2000?
Offer a very short reply. 0.94. What is the ratio of the Total Labor Force (in %) of Mexico in 1995 to that in 1996?
Give a very brief answer. 1. What is the ratio of the Total Labor Force (in %) in Poland in 1995 to that in 1996?
Make the answer very short. 1.01. What is the ratio of the Total Labor Force (in %) in Saudi Arabia in 1995 to that in 1996?
Keep it short and to the point. 0.98. What is the ratio of the Total Labor Force (in %) in Argentina in 1995 to that in 1997?
Give a very brief answer. 0.99. What is the ratio of the Total Labor Force (in %) of Mexico in 1995 to that in 1997?
Offer a very short reply. 0.95. What is the ratio of the Total Labor Force (in %) of Poland in 1995 to that in 1997?
Your answer should be very brief. 1.02. What is the ratio of the Total Labor Force (in %) of Saudi Arabia in 1995 to that in 1997?
Offer a terse response. 0.96. What is the ratio of the Total Labor Force (in %) of Argentina in 1995 to that in 1998?
Your response must be concise. 0.98. What is the ratio of the Total Labor Force (in %) in Mexico in 1995 to that in 1998?
Your answer should be compact. 0.95. What is the ratio of the Total Labor Force (in %) in Poland in 1995 to that in 1998?
Your answer should be very brief. 1.02. What is the ratio of the Total Labor Force (in %) of Saudi Arabia in 1995 to that in 1998?
Your response must be concise. 0.94. What is the ratio of the Total Labor Force (in %) in Argentina in 1995 to that in 1999?
Offer a terse response. 0.97. What is the ratio of the Total Labor Force (in %) in Mexico in 1995 to that in 1999?
Your response must be concise. 0.98. What is the ratio of the Total Labor Force (in %) in Poland in 1995 to that in 1999?
Provide a short and direct response. 1.03. What is the ratio of the Total Labor Force (in %) of Saudi Arabia in 1995 to that in 1999?
Your answer should be very brief. 0.92. What is the ratio of the Total Labor Force (in %) of Argentina in 1995 to that in 2000?
Give a very brief answer. 0.96. What is the ratio of the Total Labor Force (in %) of Poland in 1995 to that in 2000?
Your answer should be very brief. 1.02. What is the ratio of the Total Labor Force (in %) of Saudi Arabia in 1995 to that in 2000?
Your answer should be compact. 0.95. What is the ratio of the Total Labor Force (in %) of Mexico in 1996 to that in 1997?
Ensure brevity in your answer.  0.95. What is the ratio of the Total Labor Force (in %) in Poland in 1996 to that in 1997?
Give a very brief answer. 1.01. What is the ratio of the Total Labor Force (in %) in Saudi Arabia in 1996 to that in 1997?
Offer a very short reply. 0.98. What is the ratio of the Total Labor Force (in %) in Argentina in 1996 to that in 1998?
Make the answer very short. 0.99. What is the ratio of the Total Labor Force (in %) in Mexico in 1996 to that in 1998?
Your answer should be compact. 0.95. What is the ratio of the Total Labor Force (in %) of Poland in 1996 to that in 1998?
Ensure brevity in your answer.  1.01. What is the ratio of the Total Labor Force (in %) in Saudi Arabia in 1996 to that in 1998?
Offer a very short reply. 0.96. What is the ratio of the Total Labor Force (in %) in Argentina in 1996 to that in 1999?
Provide a short and direct response. 0.98. What is the ratio of the Total Labor Force (in %) of Mexico in 1996 to that in 1999?
Ensure brevity in your answer.  0.98. What is the ratio of the Total Labor Force (in %) of Poland in 1996 to that in 1999?
Offer a very short reply. 1.02. What is the ratio of the Total Labor Force (in %) of Saudi Arabia in 1996 to that in 1999?
Ensure brevity in your answer.  0.94. What is the ratio of the Total Labor Force (in %) of Argentina in 1996 to that in 2000?
Your answer should be compact. 0.97. What is the ratio of the Total Labor Force (in %) of Poland in 1996 to that in 2000?
Provide a short and direct response. 1.01. What is the ratio of the Total Labor Force (in %) in Saudi Arabia in 1996 to that in 2000?
Offer a very short reply. 0.97. What is the ratio of the Total Labor Force (in %) in Argentina in 1997 to that in 1998?
Ensure brevity in your answer.  0.99. What is the ratio of the Total Labor Force (in %) in Mexico in 1997 to that in 1998?
Make the answer very short. 1.01. What is the ratio of the Total Labor Force (in %) in Saudi Arabia in 1997 to that in 1998?
Make the answer very short. 0.98. What is the ratio of the Total Labor Force (in %) in Argentina in 1997 to that in 1999?
Offer a terse response. 0.98. What is the ratio of the Total Labor Force (in %) in Mexico in 1997 to that in 1999?
Make the answer very short. 1.03. What is the ratio of the Total Labor Force (in %) in Saudi Arabia in 1997 to that in 1999?
Provide a succinct answer. 0.96. What is the ratio of the Total Labor Force (in %) in Argentina in 1997 to that in 2000?
Your answer should be very brief. 0.97. What is the ratio of the Total Labor Force (in %) of Mexico in 1997 to that in 2000?
Make the answer very short. 1.02. What is the ratio of the Total Labor Force (in %) in Poland in 1997 to that in 2000?
Your answer should be compact. 1. What is the ratio of the Total Labor Force (in %) of Saudi Arabia in 1997 to that in 2000?
Keep it short and to the point. 0.99. What is the ratio of the Total Labor Force (in %) of Argentina in 1998 to that in 1999?
Your answer should be compact. 0.99. What is the ratio of the Total Labor Force (in %) of Mexico in 1998 to that in 1999?
Offer a terse response. 1.02. What is the ratio of the Total Labor Force (in %) in Poland in 1998 to that in 1999?
Give a very brief answer. 1.01. What is the ratio of the Total Labor Force (in %) of Saudi Arabia in 1998 to that in 1999?
Offer a terse response. 0.98. What is the ratio of the Total Labor Force (in %) of Argentina in 1998 to that in 2000?
Your answer should be very brief. 0.98. What is the ratio of the Total Labor Force (in %) of Mexico in 1998 to that in 2000?
Ensure brevity in your answer.  1.01. What is the ratio of the Total Labor Force (in %) of Saudi Arabia in 1998 to that in 2000?
Ensure brevity in your answer.  1.01. What is the ratio of the Total Labor Force (in %) of Argentina in 1999 to that in 2000?
Ensure brevity in your answer.  0.99. What is the ratio of the Total Labor Force (in %) in Mexico in 1999 to that in 2000?
Make the answer very short. 0.99. What is the ratio of the Total Labor Force (in %) in Poland in 1999 to that in 2000?
Your response must be concise. 0.99. What is the ratio of the Total Labor Force (in %) in Saudi Arabia in 1999 to that in 2000?
Make the answer very short. 1.04. What is the difference between the highest and the second highest Total Labor Force (in %) of Mexico?
Your answer should be very brief. 0.3. What is the difference between the highest and the second highest Total Labor Force (in %) of Saudi Arabia?
Your answer should be very brief. 0.4. What is the difference between the highest and the lowest Total Labor Force (in %) in Mexico?
Give a very brief answer. 4.2. What is the difference between the highest and the lowest Total Labor Force (in %) in Poland?
Offer a very short reply. 3.7. What is the difference between the highest and the lowest Total Labor Force (in %) of Saudi Arabia?
Offer a terse response. 2. 